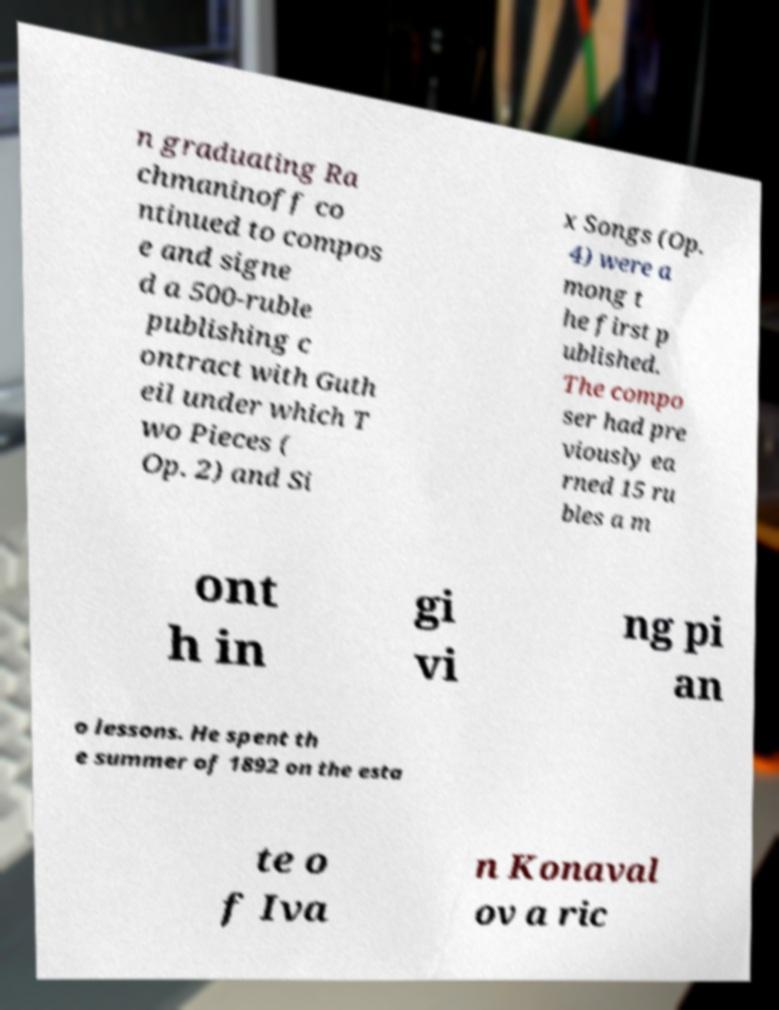Please read and relay the text visible in this image. What does it say? n graduating Ra chmaninoff co ntinued to compos e and signe d a 500-ruble publishing c ontract with Guth eil under which T wo Pieces ( Op. 2) and Si x Songs (Op. 4) were a mong t he first p ublished. The compo ser had pre viously ea rned 15 ru bles a m ont h in gi vi ng pi an o lessons. He spent th e summer of 1892 on the esta te o f Iva n Konaval ov a ric 